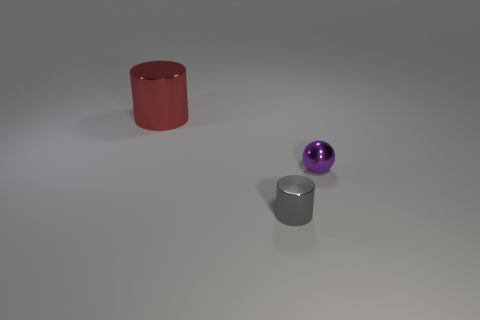Add 3 tiny cylinders. How many objects exist? 6 Subtract all cylinders. How many objects are left? 1 Subtract 1 spheres. How many spheres are left? 0 Subtract all red cylinders. Subtract all gray spheres. How many cylinders are left? 1 Subtract all brown cylinders. How many gray spheres are left? 0 Subtract all tiny gray cylinders. Subtract all small shiny objects. How many objects are left? 0 Add 1 tiny gray cylinders. How many tiny gray cylinders are left? 2 Add 2 large matte balls. How many large matte balls exist? 2 Subtract 0 yellow cylinders. How many objects are left? 3 